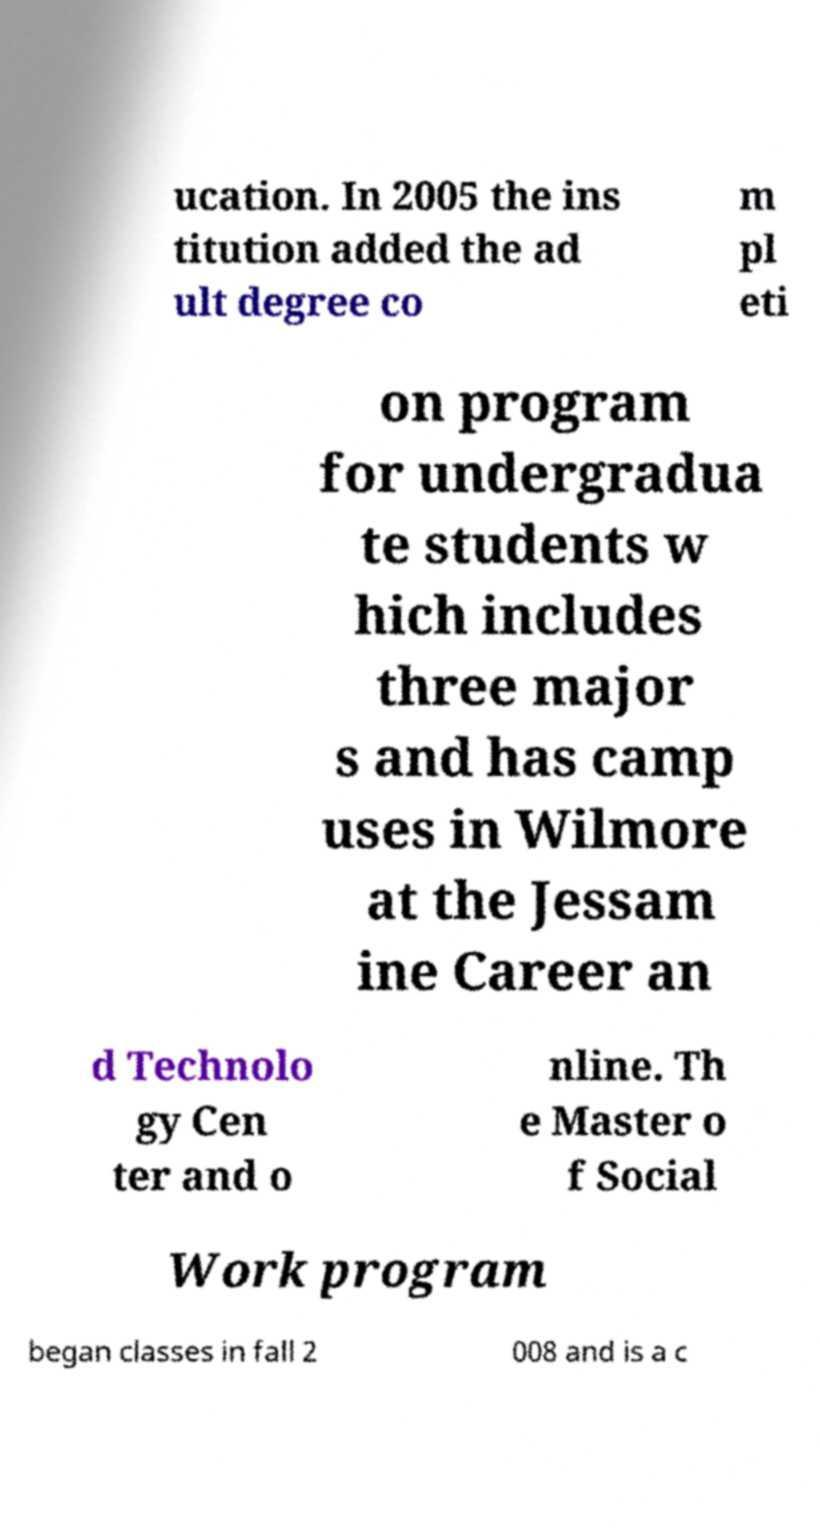Can you accurately transcribe the text from the provided image for me? ucation. In 2005 the ins titution added the ad ult degree co m pl eti on program for undergradua te students w hich includes three major s and has camp uses in Wilmore at the Jessam ine Career an d Technolo gy Cen ter and o nline. Th e Master o f Social Work program began classes in fall 2 008 and is a c 